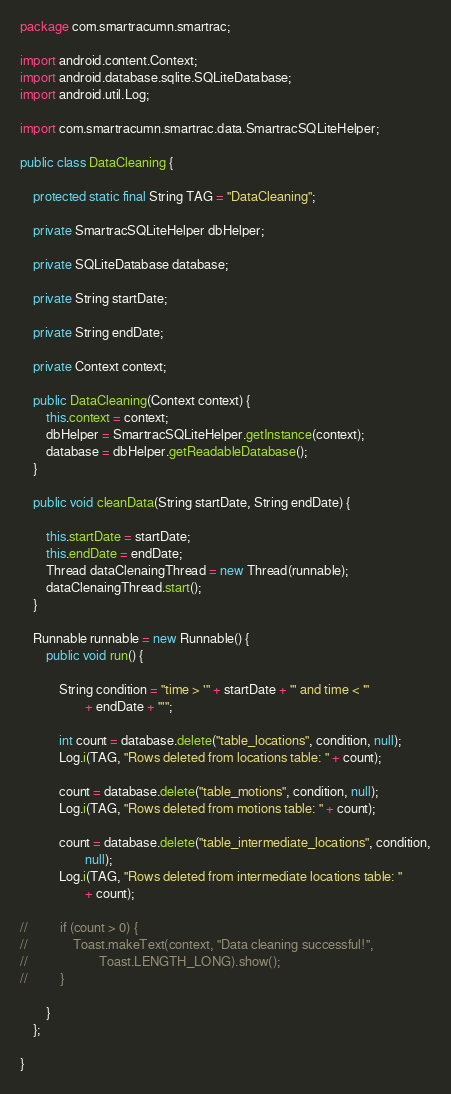Convert code to text. <code><loc_0><loc_0><loc_500><loc_500><_Java_>package com.smartracumn.smartrac;

import android.content.Context;
import android.database.sqlite.SQLiteDatabase;
import android.util.Log;

import com.smartracumn.smartrac.data.SmartracSQLiteHelper;

public class DataCleaning {

	protected static final String TAG = "DataCleaning";

	private SmartracSQLiteHelper dbHelper;

	private SQLiteDatabase database;

	private String startDate;

	private String endDate;

	private Context context;

	public DataCleaning(Context context) {
		this.context = context;
		dbHelper = SmartracSQLiteHelper.getInstance(context);
		database = dbHelper.getReadableDatabase();
	}

	public void cleanData(String startDate, String endDate) {

		this.startDate = startDate;
		this.endDate = endDate;
		Thread dataClenaingThread = new Thread(runnable);
		dataClenaingThread.start();
	}

	Runnable runnable = new Runnable() {
		public void run() {

			String condition = "time > '" + startDate + "' and time < '"
					+ endDate + "'";

			int count = database.delete("table_locations", condition, null);
			Log.i(TAG, "Rows deleted from locations table: " + count);

			count = database.delete("table_motions", condition, null);
			Log.i(TAG, "Rows deleted from motions table: " + count);

			count = database.delete("table_intermediate_locations", condition,
					null);
			Log.i(TAG, "Rows deleted from intermediate locations table: "
					+ count);

//			if (count > 0) {
//				Toast.makeText(context, "Data cleaning successful!",
//						Toast.LENGTH_LONG).show();
//			}

		}
	};

}
</code> 